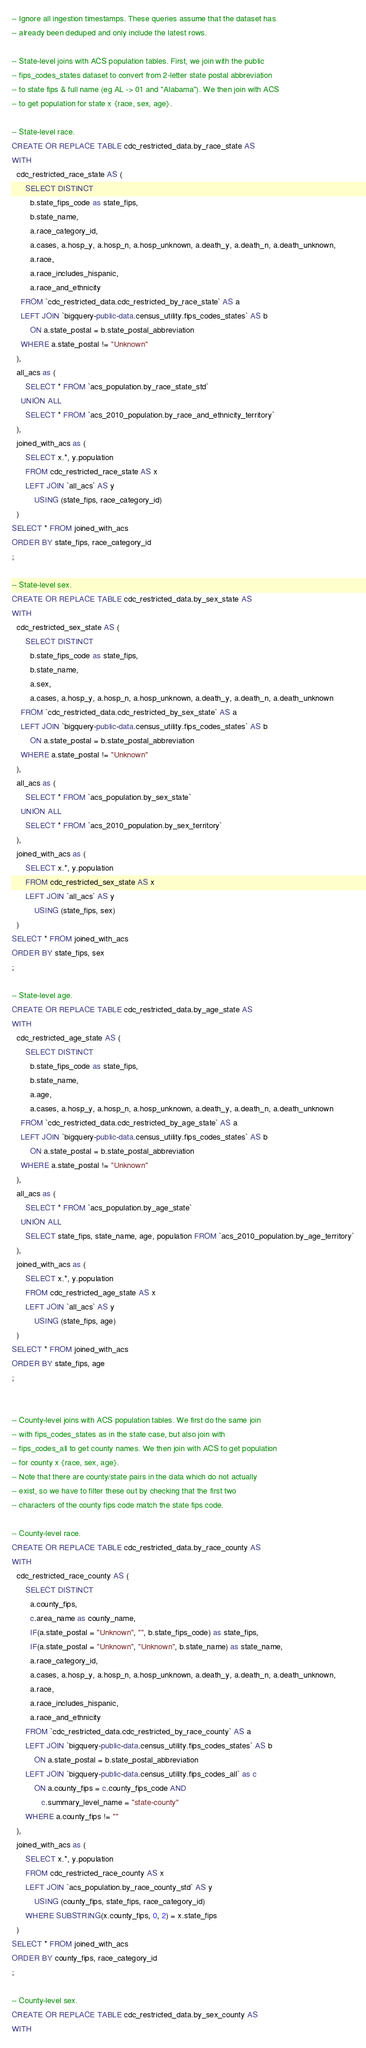Convert code to text. <code><loc_0><loc_0><loc_500><loc_500><_SQL_>-- Ignore all ingestion timestamps. These queries assume that the dataset has
-- already been deduped and only include the latest rows.

-- State-level joins with ACS population tables. First, we join with the public
-- fips_codes_states dataset to convert from 2-letter state postal abbreviation
-- to state fips & full name (eg AL -> 01 and "Alabama"). We then join with ACS
-- to get population for state x {race, sex, age}.

-- State-level race.
CREATE OR REPLACE TABLE cdc_restricted_data.by_race_state AS
WITH
  cdc_restricted_race_state AS (
      SELECT DISTINCT
        b.state_fips_code as state_fips,
        b.state_name,
        a.race_category_id,
        a.cases, a.hosp_y, a.hosp_n, a.hosp_unknown, a.death_y, a.death_n, a.death_unknown,
        a.race,
        a.race_includes_hispanic,
        a.race_and_ethnicity
    FROM `cdc_restricted_data.cdc_restricted_by_race_state` AS a
    LEFT JOIN `bigquery-public-data.census_utility.fips_codes_states` AS b
        ON a.state_postal = b.state_postal_abbreviation
    WHERE a.state_postal != "Unknown"
  ),
  all_acs as (
      SELECT * FROM `acs_population.by_race_state_std`
    UNION ALL
      SELECT * FROM `acs_2010_population.by_race_and_ethnicity_territory`
  ),
  joined_with_acs as (
      SELECT x.*, y.population
      FROM cdc_restricted_race_state AS x
      LEFT JOIN `all_acs` AS y
          USING (state_fips, race_category_id)
  )
SELECT * FROM joined_with_acs
ORDER BY state_fips, race_category_id
;

-- State-level sex.
CREATE OR REPLACE TABLE cdc_restricted_data.by_sex_state AS
WITH
  cdc_restricted_sex_state AS (
      SELECT DISTINCT
        b.state_fips_code as state_fips,
        b.state_name,
        a.sex,
        a.cases, a.hosp_y, a.hosp_n, a.hosp_unknown, a.death_y, a.death_n, a.death_unknown
    FROM `cdc_restricted_data.cdc_restricted_by_sex_state` AS a
    LEFT JOIN `bigquery-public-data.census_utility.fips_codes_states` AS b
        ON a.state_postal = b.state_postal_abbreviation
    WHERE a.state_postal != "Unknown"
  ),
  all_acs as (
      SELECT * FROM `acs_population.by_sex_state`
    UNION ALL
      SELECT * FROM `acs_2010_population.by_sex_territory`
  ),
  joined_with_acs as (
      SELECT x.*, y.population
      FROM cdc_restricted_sex_state AS x
      LEFT JOIN `all_acs` AS y
          USING (state_fips, sex)
  )
SELECT * FROM joined_with_acs
ORDER BY state_fips, sex
;

-- State-level age.
CREATE OR REPLACE TABLE cdc_restricted_data.by_age_state AS
WITH
  cdc_restricted_age_state AS (
      SELECT DISTINCT
        b.state_fips_code as state_fips,
        b.state_name,
        a.age,
        a.cases, a.hosp_y, a.hosp_n, a.hosp_unknown, a.death_y, a.death_n, a.death_unknown
    FROM `cdc_restricted_data.cdc_restricted_by_age_state` AS a
    LEFT JOIN `bigquery-public-data.census_utility.fips_codes_states` AS b
        ON a.state_postal = b.state_postal_abbreviation
    WHERE a.state_postal != "Unknown"
  ),
  all_acs as (
      SELECT * FROM `acs_population.by_age_state`
    UNION ALL
      SELECT state_fips, state_name, age, population FROM `acs_2010_population.by_age_territory`
  ),
  joined_with_acs as (
      SELECT x.*, y.population
      FROM cdc_restricted_age_state AS x
      LEFT JOIN `all_acs` AS y
          USING (state_fips, age)
  )
SELECT * FROM joined_with_acs
ORDER BY state_fips, age
;


-- County-level joins with ACS population tables. We first do the same join
-- with fips_codes_states as in the state case, but also join with
-- fips_codes_all to get county names. We then join with ACS to get population
-- for county x {race, sex, age}.
-- Note that there are county/state pairs in the data which do not actually
-- exist, so we have to filter these out by checking that the first two
-- characters of the county fips code match the state fips code.

-- County-level race.
CREATE OR REPLACE TABLE cdc_restricted_data.by_race_county AS
WITH
  cdc_restricted_race_county AS (
      SELECT DISTINCT
        a.county_fips,
        c.area_name as county_name,
        IF(a.state_postal = "Unknown", "", b.state_fips_code) as state_fips,
        IF(a.state_postal = "Unknown", "Unknown", b.state_name) as state_name,
        a.race_category_id,
        a.cases, a.hosp_y, a.hosp_n, a.hosp_unknown, a.death_y, a.death_n, a.death_unknown,
        a.race,
        a.race_includes_hispanic,
        a.race_and_ethnicity
      FROM `cdc_restricted_data.cdc_restricted_by_race_county` AS a
      LEFT JOIN `bigquery-public-data.census_utility.fips_codes_states` AS b
          ON a.state_postal = b.state_postal_abbreviation
      LEFT JOIN `bigquery-public-data.census_utility.fips_codes_all` as c
          ON a.county_fips = c.county_fips_code AND
             c.summary_level_name = "state-county"
      WHERE a.county_fips != ""
  ),
  joined_with_acs as (
      SELECT x.*, y.population
      FROM cdc_restricted_race_county AS x
      LEFT JOIN `acs_population.by_race_county_std` AS y
          USING (county_fips, state_fips, race_category_id)
      WHERE SUBSTRING(x.county_fips, 0, 2) = x.state_fips
  )
SELECT * FROM joined_with_acs
ORDER BY county_fips, race_category_id
;

-- County-level sex.
CREATE OR REPLACE TABLE cdc_restricted_data.by_sex_county AS
WITH</code> 